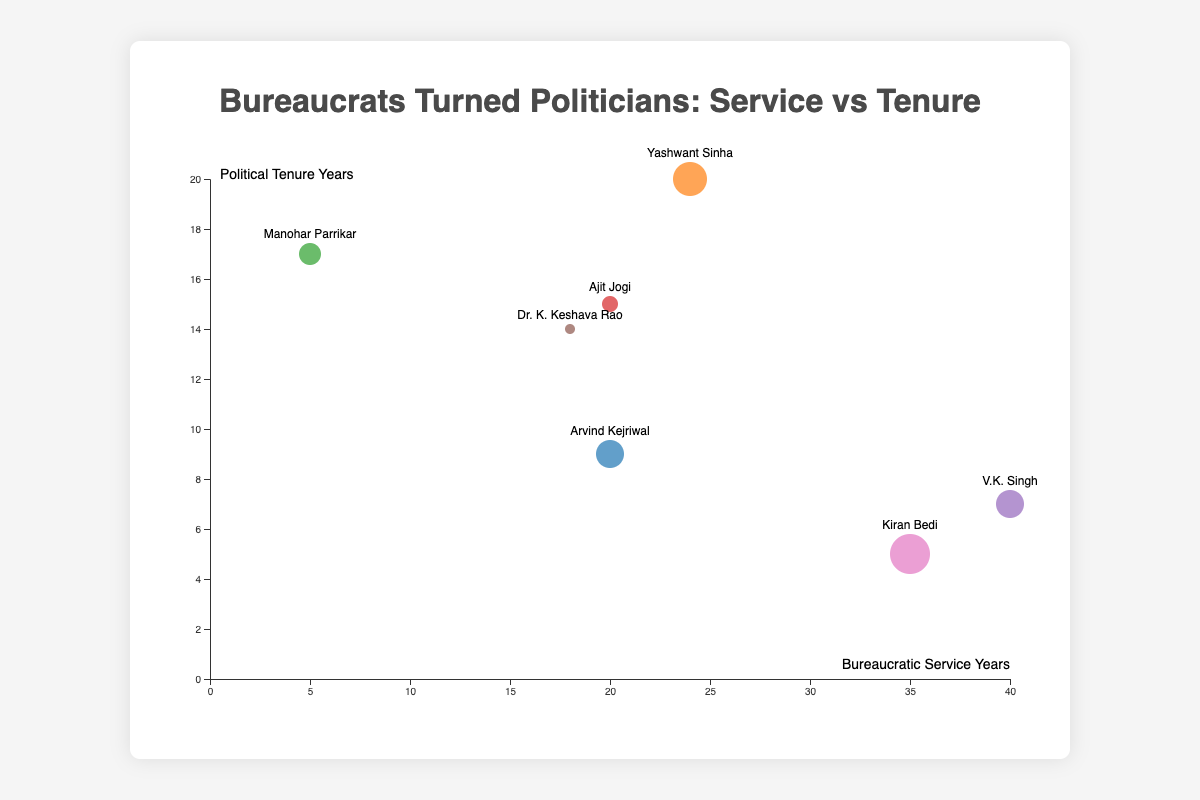What is the title of the figure? The title is displayed at the top center of the figure.
Answer: Bureaucrats Turned Politicians: Service vs Tenure How many data points are represented in the chart? Each circle on the chart represents a data point, and there are seven circles in total.
Answer: 7 Who has the longest bureaucratic service before entering politics? By observing the horizontal position of the circles along the x-axis, the circle furthest to the right represents the person with the longest bureaucratic service, which is V.K. Singh with 40 years.
Answer: V.K. Singh Which bureaucrat-turned-politician has the smallest circle size? Circle sizes are visually different, and the smallest circle corresponds to Dr. K. Keshava Rao with a size of 7.
Answer: Dr. K. Keshava Rao Who has a political tenure of 20 years? Checking the vertical position of circles along the y-axis, the circle at 20 years of political tenure represents Yashwant Sinha.
Answer: Yashwant Sinha Which individual has the highest combined years of bureaucratic service and political tenure? Adding up both values for each individual: Arvind Kejriwal (29), Yashwant Sinha (44), Manohar Parrikar (22), Ajit Jogi (35), V.K. Singh (47), Dr. K. Keshava Rao (32), and Kiran Bedi (40). V.K. Singh has the highest combined total.
Answer: V.K. Singh Compare the political tenure of Arvind Kejriwal and Kiran Bedi. Who has served longer in politics? Comparing the y-axis positions for Arvind Kejriwal (9 years) and Kiran Bedi (5 years), Arvind Kejriwal has a longer political tenure.
Answer: Arvind Kejriwal Which individual has the circular marker with the largest radius? Visually identifying the largest circle size in the chart, Kiran Bedi’s circle has the largest radius with a size of 12.
Answer: Kiran Bedi Is there any individual who has less than 10 years of political tenure but more than 30 years of bureaucratic service? Checking the points in the x-axis greater than 30 years and y-axis less than 10 years, V.K. Singh (40 years service, 7 years tenure) and Kiran Bedi (35 years service, 5 years tenure) meet these criteria.
Answer: Yes, V.K. Singh and Kiran Bedi Who has the closest balance between years in bureaucratic service and political tenure? Looking for the individual with the smallest difference between bureaucratic service and political tenure: Arvind Kejriwal (11), Yashwant Sinha (4), Manohar Parrikar (12), Ajit Jogi (5), V.K. Singh (33), Dr. K. Keshava Rao (4), Kiran Bedi (30). Yashwant Sinha and Dr. K. Keshava Rao both have an equal and smallest difference of 4.
Answer: Yashwant Sinha and Dr. K. Keshava Rao 